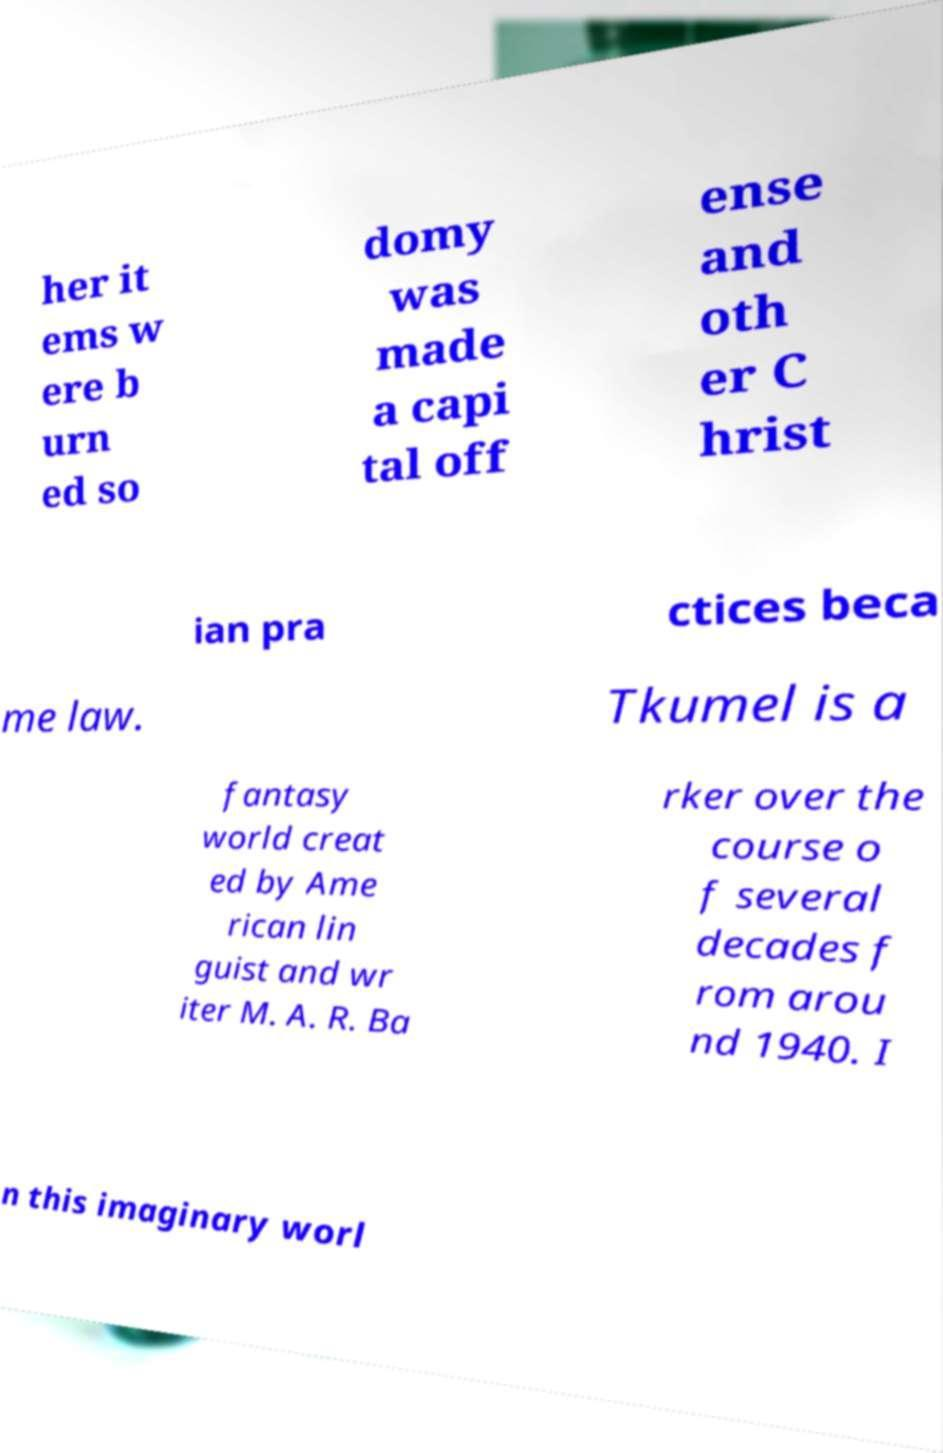I need the written content from this picture converted into text. Can you do that? her it ems w ere b urn ed so domy was made a capi tal off ense and oth er C hrist ian pra ctices beca me law. Tkumel is a fantasy world creat ed by Ame rican lin guist and wr iter M. A. R. Ba rker over the course o f several decades f rom arou nd 1940. I n this imaginary worl 